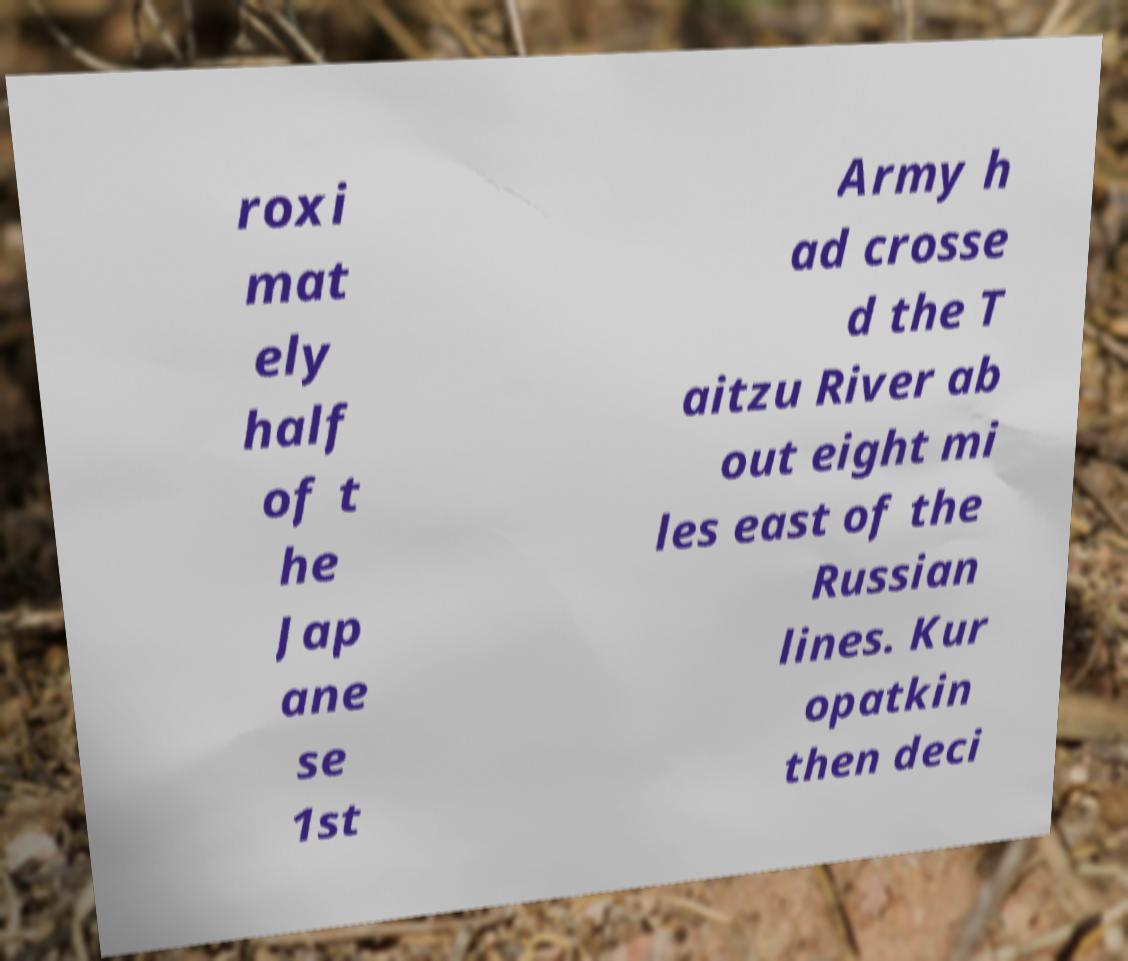Could you assist in decoding the text presented in this image and type it out clearly? roxi mat ely half of t he Jap ane se 1st Army h ad crosse d the T aitzu River ab out eight mi les east of the Russian lines. Kur opatkin then deci 